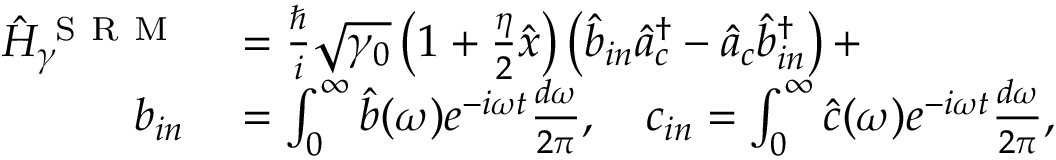Convert formula to latex. <formula><loc_0><loc_0><loc_500><loc_500>\begin{array} { r l } { \hat { H } _ { \gamma } ^ { S R M } } & = \frac { \hslash } { i } \sqrt { \gamma _ { 0 } } \left ( 1 + \frac { \eta } { 2 } \hat { x } \right ) \left ( \hat { b } _ { i n } \hat { a } _ { c } ^ { \dagger } - \hat { a } _ { c } \hat { b } _ { i n } ^ { \dag } \right ) + } \\ { b _ { i n } } & = \int _ { 0 } ^ { \infty } \hat { b } ( \omega ) e ^ { - i \omega t } \frac { d \omega } { 2 \pi } , \quad c _ { i n } = \int _ { 0 } ^ { \infty } \hat { c } ( \omega ) e ^ { - i \omega t } \frac { d \omega } { 2 \pi } , } \end{array}</formula> 